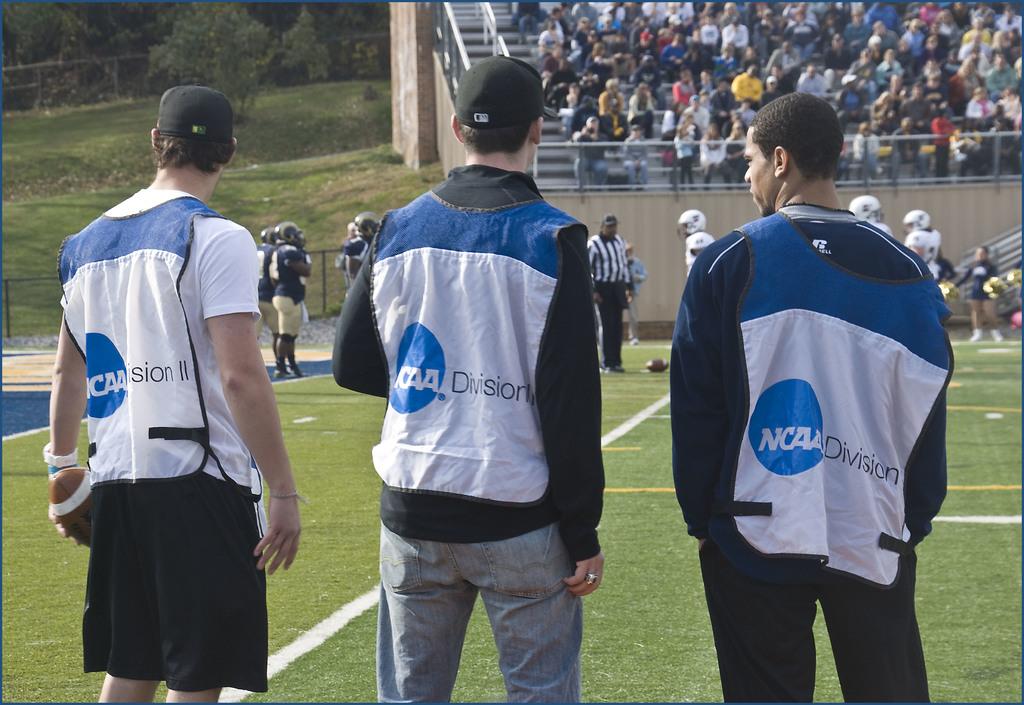What division is on the vests?
Offer a very short reply. Ncaa. What does it say in the blue bubble on the shirts?
Your answer should be compact. Ncaa. 